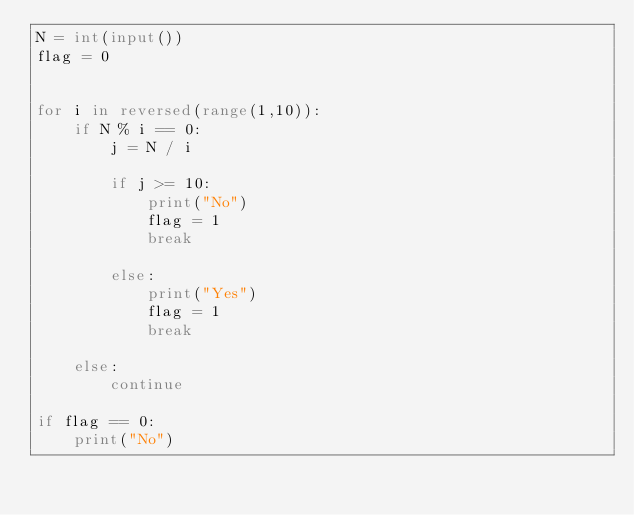Convert code to text. <code><loc_0><loc_0><loc_500><loc_500><_Python_>N = int(input())
flag = 0


for i in reversed(range(1,10)):
    if N % i == 0:
        j = N / i

        if j >= 10:
            print("No")
            flag = 1
            break

        else:
            print("Yes")
            flag = 1
            break

    else:
        continue

if flag == 0:
    print("No")</code> 